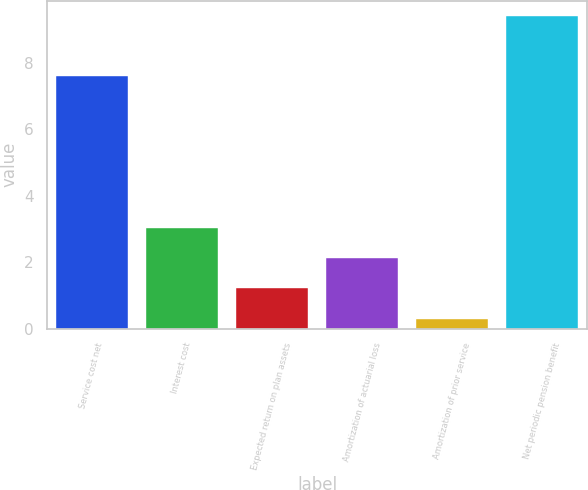Convert chart. <chart><loc_0><loc_0><loc_500><loc_500><bar_chart><fcel>Service cost net<fcel>Interest cost<fcel>Expected return on plan assets<fcel>Amortization of actuarial loss<fcel>Amortization of prior service<fcel>Net periodic pension benefit<nl><fcel>7.6<fcel>3.03<fcel>1.21<fcel>2.12<fcel>0.3<fcel>9.4<nl></chart> 